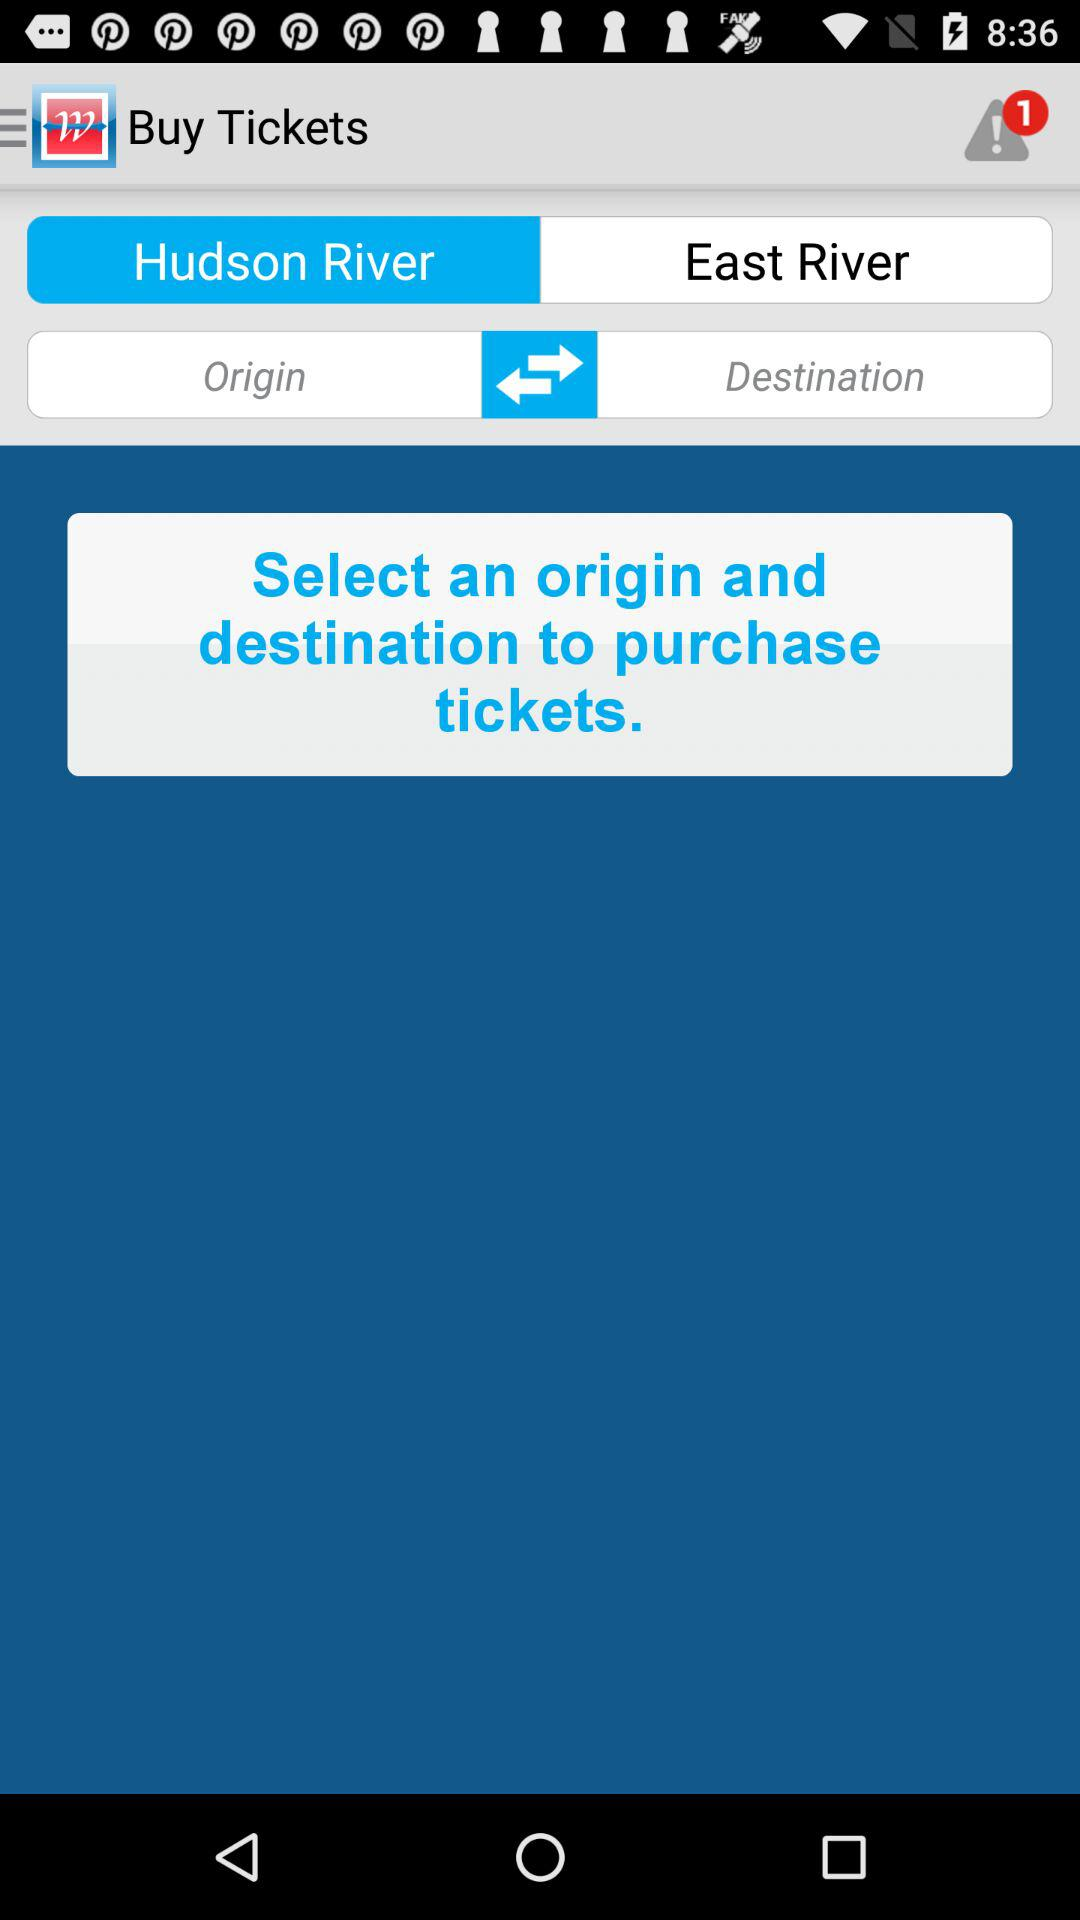How many notifications are shown? There is 1 notification. 